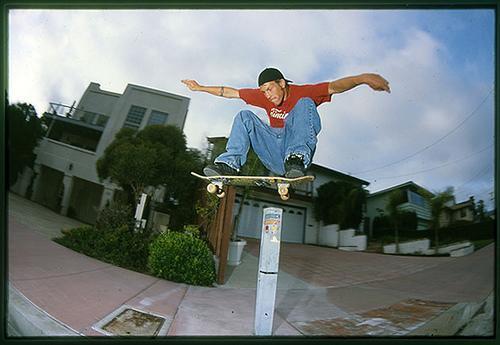How many pieces of sports equipment are featured in the picture?
Give a very brief answer. 1. How many bikes are present?
Give a very brief answer. 0. 